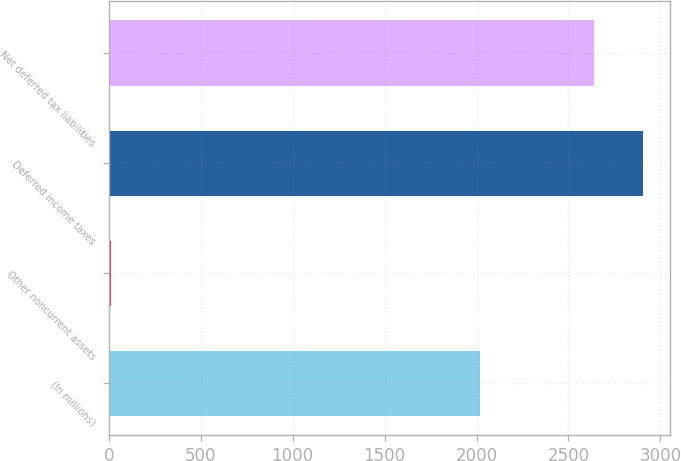Convert chart. <chart><loc_0><loc_0><loc_500><loc_500><bar_chart><fcel>(In millions)<fcel>Other noncurrent assets<fcel>Deferred income taxes<fcel>Net deferred tax liabilities<nl><fcel>2017<fcel>13<fcel>2905.1<fcel>2641<nl></chart> 